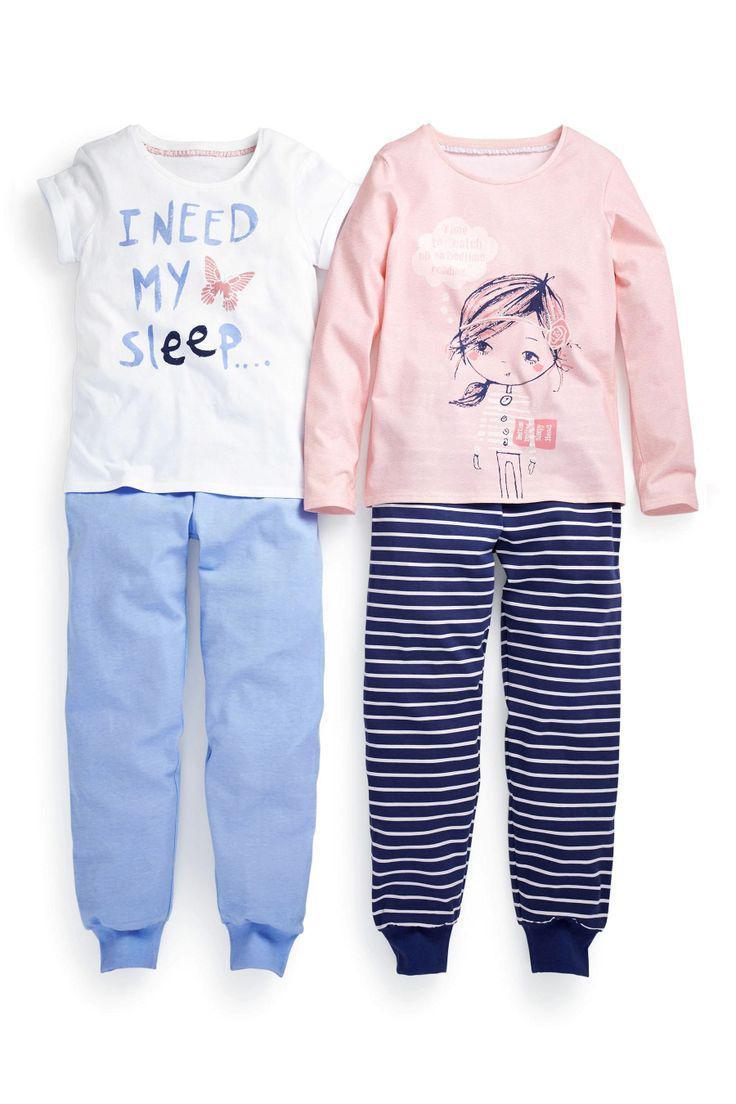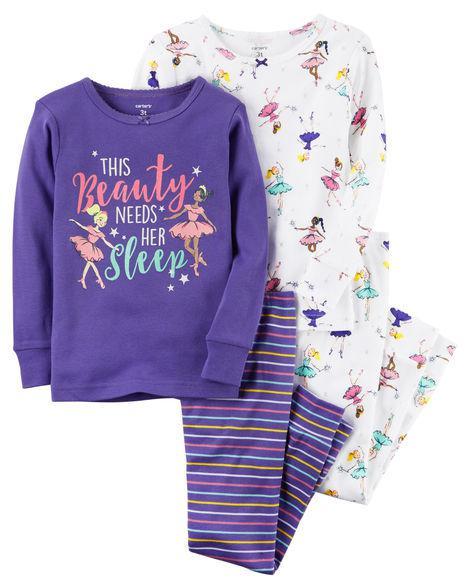The first image is the image on the left, the second image is the image on the right. Given the left and right images, does the statement "None of the pants have vertical or horizontal stripes." hold true? Answer yes or no. No. The first image is the image on the left, the second image is the image on the right. For the images displayed, is the sentence "An image includes a short-sleeve top and a pair of striped pants." factually correct? Answer yes or no. Yes. 